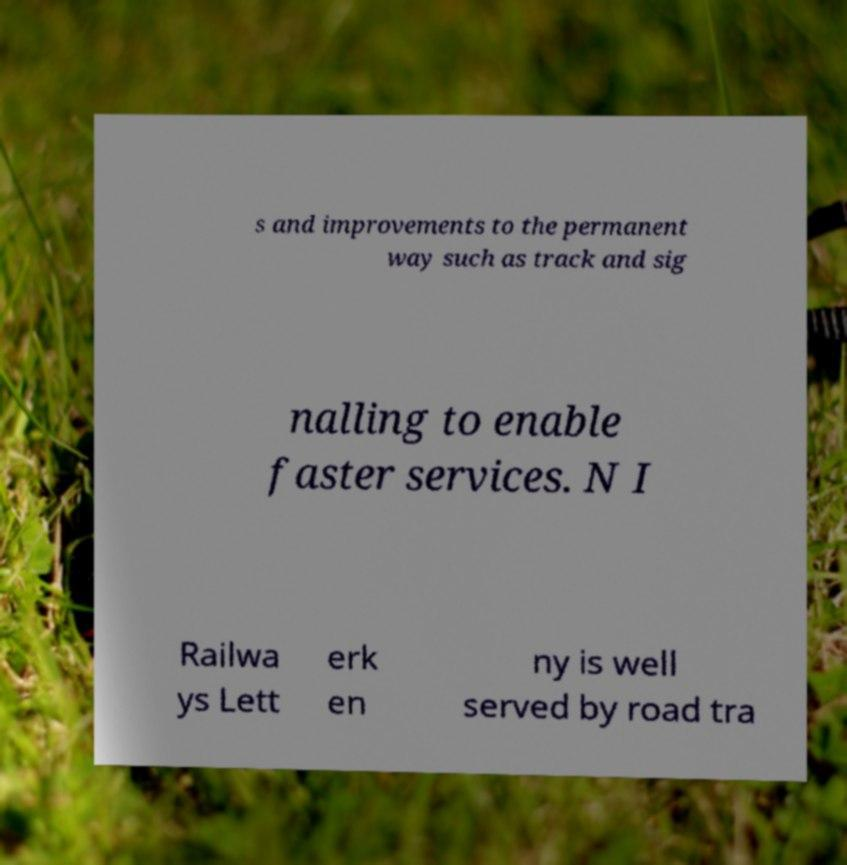Can you read and provide the text displayed in the image?This photo seems to have some interesting text. Can you extract and type it out for me? s and improvements to the permanent way such as track and sig nalling to enable faster services. N I Railwa ys Lett erk en ny is well served by road tra 